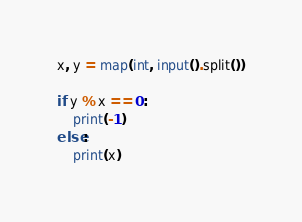Convert code to text. <code><loc_0><loc_0><loc_500><loc_500><_Python_>x, y = map(int, input().split())

if y % x == 0:
    print(-1)
else:
    print(x)</code> 